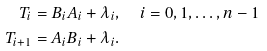<formula> <loc_0><loc_0><loc_500><loc_500>T _ { i } & = B _ { i } A _ { i } + \lambda _ { i } , \quad i = 0 , 1 , \dots , { n - 1 } \\ T _ { i + 1 } & = A _ { i } B _ { i } + \lambda _ { i } .</formula> 